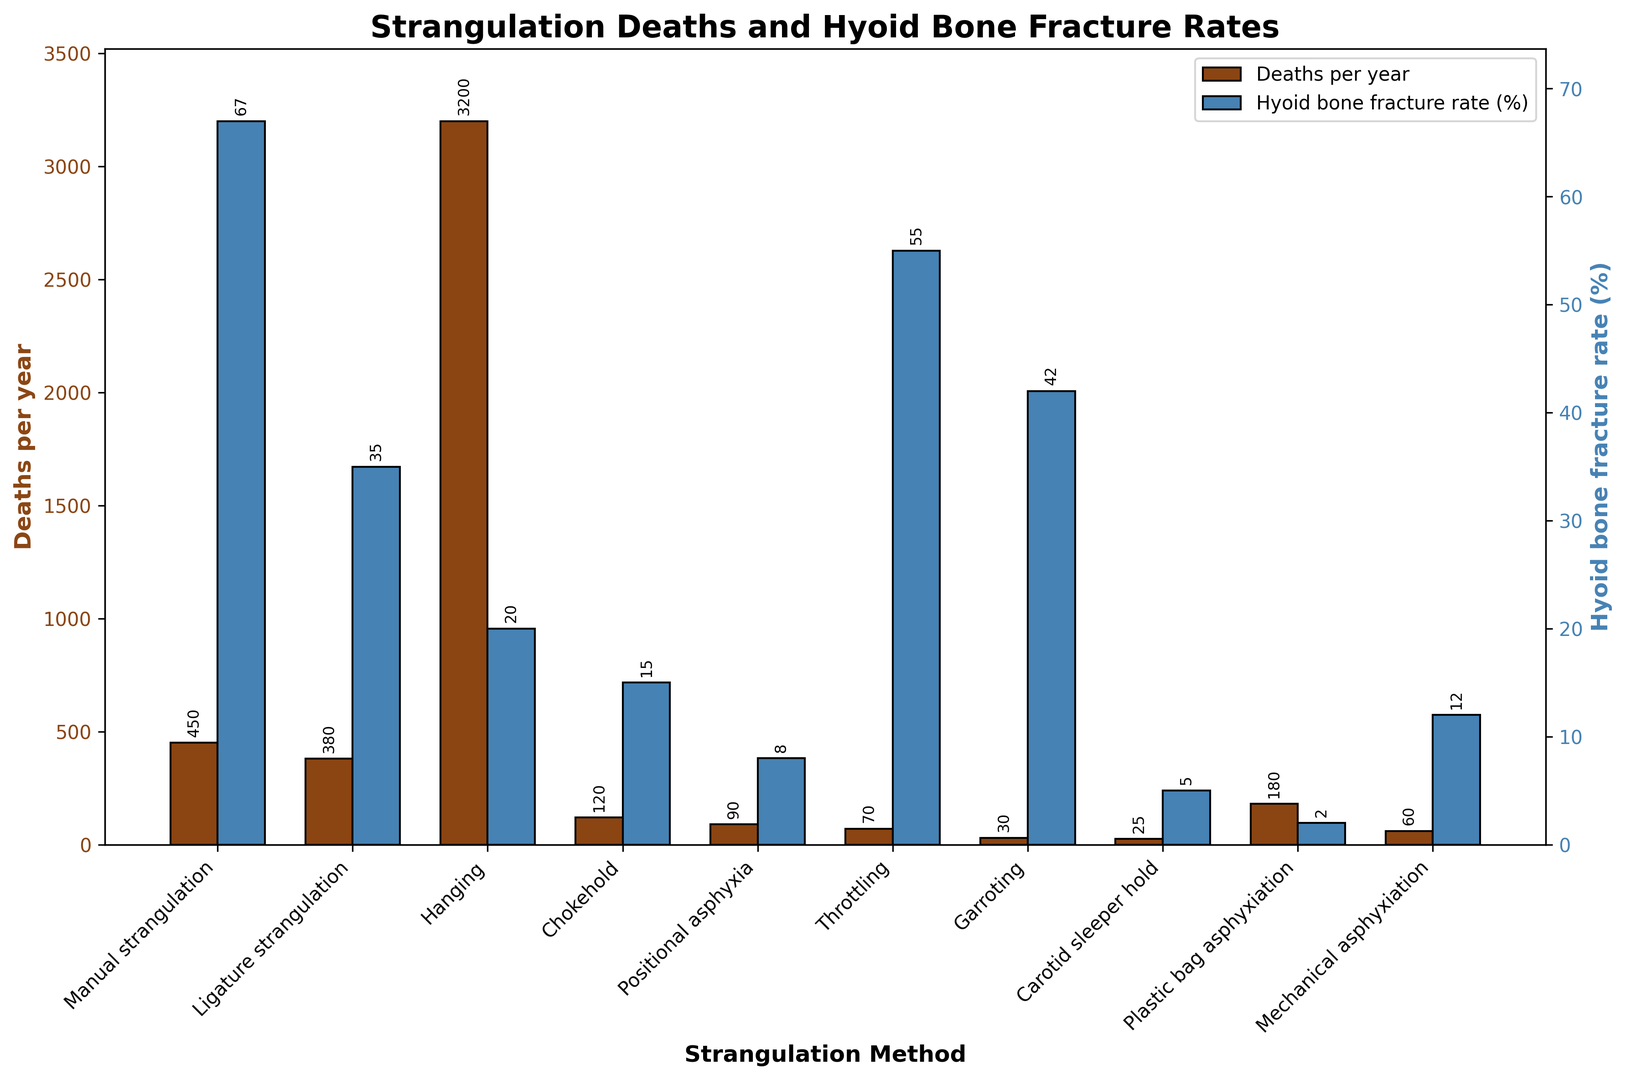Which strangulation method has the highest number of deaths per year? To find the strangulation method with the highest number of deaths per year, look at the bar heights on the left y-axis (Deaths per year). The highest bar corresponds to the method with the most deaths.
Answer: Hanging Which strangulation method has the highest hyoid bone fracture rate? To identify the method with the highest hyoid bone fracture rate, check the bar heights on the right y-axis (Hyoid bone fracture rate). The tallest bar indicates the highest rate.
Answer: Manual strangulation What is the approximate difference in hyoid bone fracture rates between Manual strangulation and Ligature strangulation? First, identify the fracture rates for Manual strangulation (67%) and Ligature strangulation (35%) from the blue bars. Then, subtract the smaller rate from the larger one: 67% - 35% = 32%
Answer: 32% Compare the number of deaths per year for Chokehold and Throttling. Which is higher? Look at the brown bars for Chokehold and Throttling. The bar that is taller indicates a higher number of deaths per year.
Answer: Chokehold Are there any methods with fewer than 100 deaths per year but a hyoid bone fracture rate over 40%? If so, which ones? Scan for methods with brown bars under 100 and blue bars over 40%. Only Garroting fits this criterion with 30 deaths per year and a 42% fracture rate.
Answer: Garroting Based on the figure, what is the total number of deaths per year for all methods combined? Add all the "Deaths per year" values from the brown bars: 450 + 380 + 3200 + 120 + 90 + 70 + 30 + 25 + 180 + 60 = 4605
Answer: 4605 What's the average hyoid bone fracture rate (%) among all the strangulation methods? Sum all the fracture rates and divide by the number of methods: (67 + 35 + 20 + 15 + 8 + 55 + 42 + 5 + 2 + 12) / 10 = 26.1%
Answer: 26.1% Which strangulation method has the closest number of deaths per year to Ligature strangulation? Check the brown bars near the Ligature strangulation value (380). Manual strangulation with 450 deaths per year is the closest.
Answer: Manual strangulation Can you list the methods with a higher hyoid bone fracture rate than Plastic bag asphyxiation? Find the fracture rate for Plastic bag asphyxiation (2%) and identify all methods with blue bars higher than this rate. The methods are: Manual strangulation, Ligature strangulation, Hanging, Chokehold, Positional asphyxia, Throttling, Garroting, and Mechanical asphyxiation.
Answer: Manual strangulation, Ligature strangulation, Hanging, Chokehold, Positional asphyxia, Throttling, Garroting, Mechanical asphyxiation 